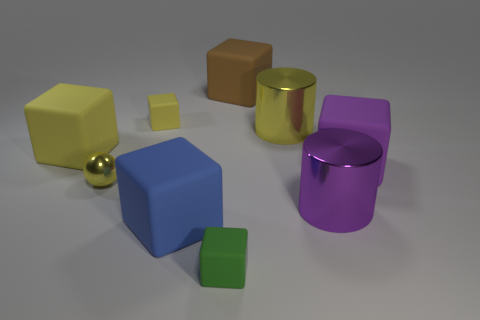Subtract all blue cylinders. How many yellow cubes are left? 2 Subtract all purple matte blocks. How many blocks are left? 5 Subtract 3 cubes. How many cubes are left? 3 Subtract all blue blocks. How many blocks are left? 5 Add 1 things. How many objects exist? 10 Subtract all spheres. How many objects are left? 8 Subtract all green cubes. Subtract all blue balls. How many cubes are left? 5 Add 1 big purple rubber blocks. How many big purple rubber blocks exist? 2 Subtract 0 red cylinders. How many objects are left? 9 Subtract all purple rubber blocks. Subtract all large blue blocks. How many objects are left? 7 